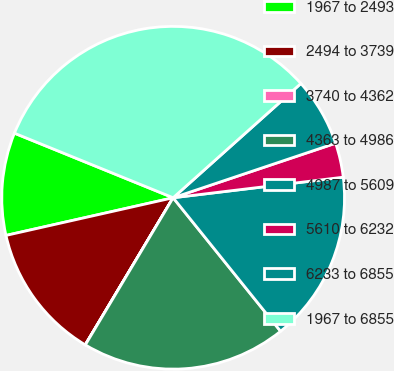Convert chart to OTSL. <chart><loc_0><loc_0><loc_500><loc_500><pie_chart><fcel>1967 to 2493<fcel>2494 to 3739<fcel>3740 to 4362<fcel>4363 to 4986<fcel>4987 to 5609<fcel>5610 to 6232<fcel>6233 to 6855<fcel>1967 to 6855<nl><fcel>9.68%<fcel>12.9%<fcel>0.01%<fcel>19.35%<fcel>16.13%<fcel>3.24%<fcel>6.46%<fcel>32.24%<nl></chart> 